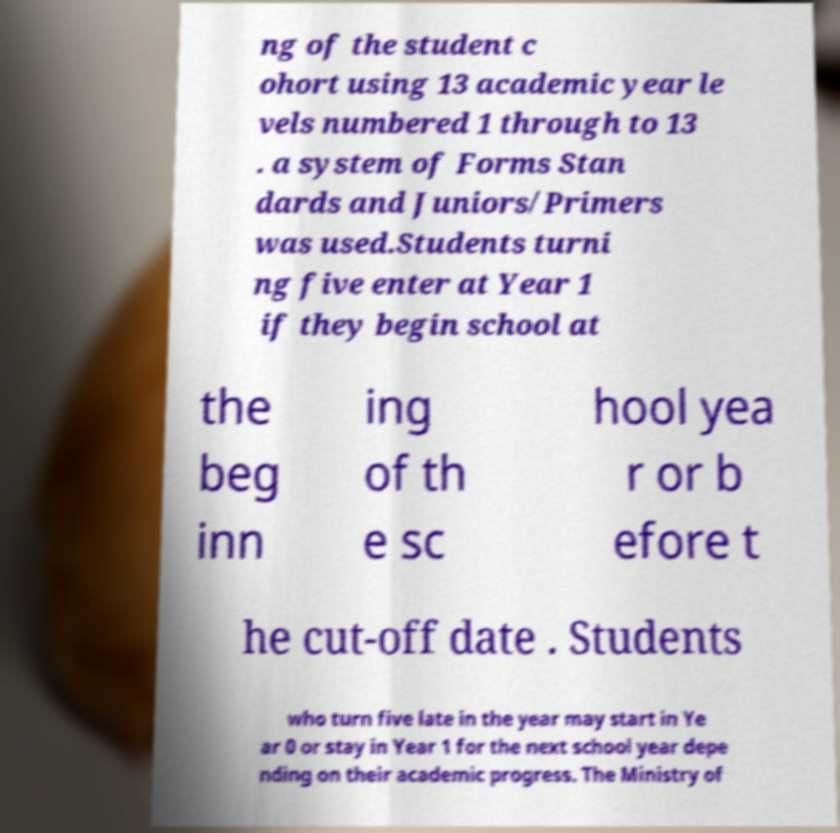What messages or text are displayed in this image? I need them in a readable, typed format. ng of the student c ohort using 13 academic year le vels numbered 1 through to 13 . a system of Forms Stan dards and Juniors/Primers was used.Students turni ng five enter at Year 1 if they begin school at the beg inn ing of th e sc hool yea r or b efore t he cut-off date . Students who turn five late in the year may start in Ye ar 0 or stay in Year 1 for the next school year depe nding on their academic progress. The Ministry of 